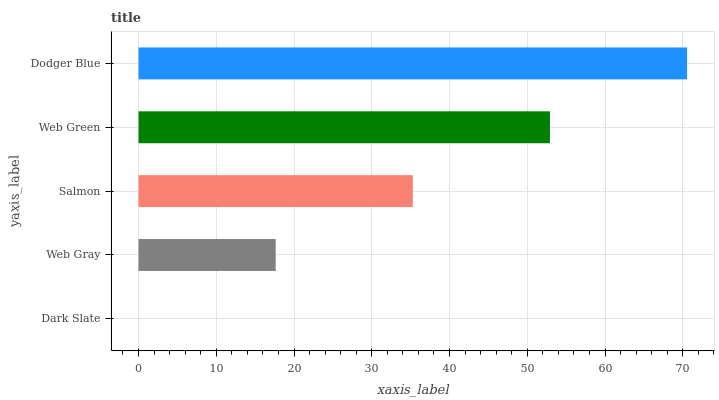Is Dark Slate the minimum?
Answer yes or no. Yes. Is Dodger Blue the maximum?
Answer yes or no. Yes. Is Web Gray the minimum?
Answer yes or no. No. Is Web Gray the maximum?
Answer yes or no. No. Is Web Gray greater than Dark Slate?
Answer yes or no. Yes. Is Dark Slate less than Web Gray?
Answer yes or no. Yes. Is Dark Slate greater than Web Gray?
Answer yes or no. No. Is Web Gray less than Dark Slate?
Answer yes or no. No. Is Salmon the high median?
Answer yes or no. Yes. Is Salmon the low median?
Answer yes or no. Yes. Is Dark Slate the high median?
Answer yes or no. No. Is Dodger Blue the low median?
Answer yes or no. No. 